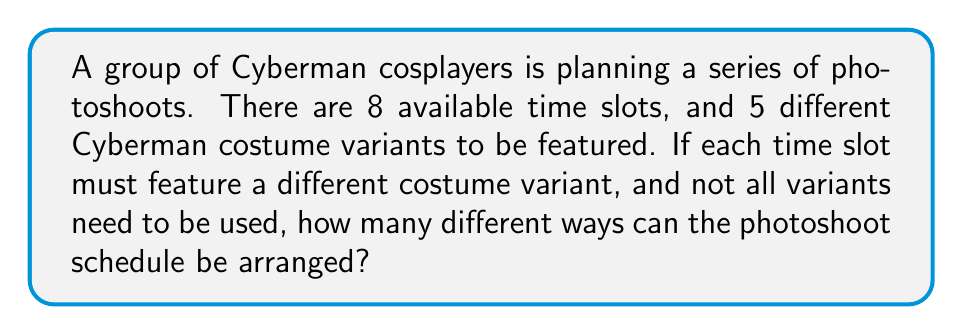Can you answer this question? Let's approach this step-by-step:

1) This is a permutation problem, as the order of the costumes matters in the schedule.

2) We need to select costumes for 8 time slots from 5 different variants.

3) For each time slot, we have a choice of any of the 5 variants that haven't been used yet.

4) This can be represented mathematically as:

   $$5 \cdot 4 \cdot 3 \cdot 2 \cdot 1 \cdot 1 \cdot 1 \cdot 1$$

5) We can simplify this as:

   $$5! \cdot 1^3$$

6) This is because:
   - For the first slot, we have 5 choices
   - For the second slot, we have 4 choices
   - For the third slot, we have 3 choices
   - For the fourth slot, we have 2 choices
   - For the fifth slot, we have 1 choice
   - For the remaining 3 slots, we still have 1 choice each (to leave empty or repeat a variant)

7) Calculate:
   $$5! \cdot 1^3 = 120 \cdot 1 = 120$$

Therefore, there are 120 different ways to arrange the photoshoot schedule.
Answer: 120 